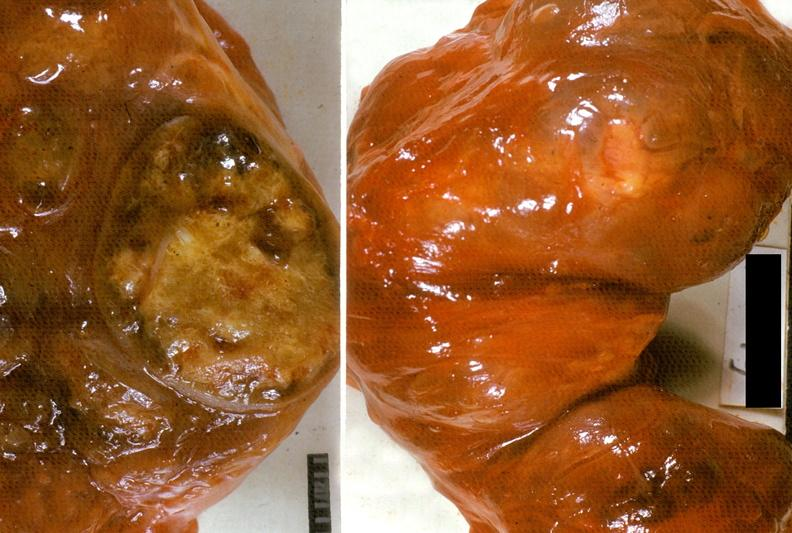does this image show thyroid, nodular goiter?
Answer the question using a single word or phrase. Yes 